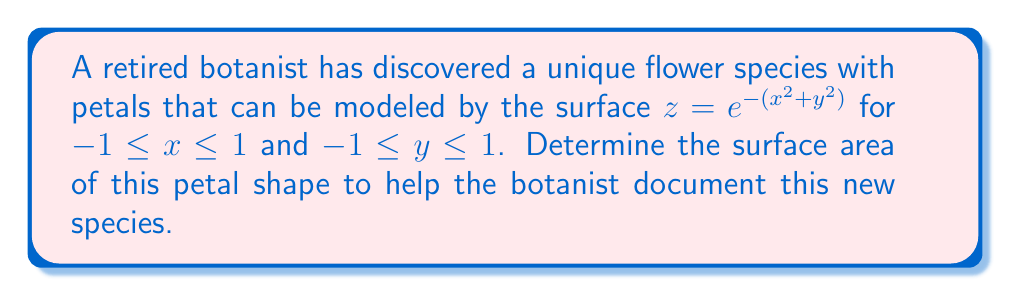Could you help me with this problem? To find the surface area of the petal, we need to use the surface area formula for a parametric surface:

$$A = \int\int_R \sqrt{1 + \left(\frac{\partial z}{\partial x}\right)^2 + \left(\frac{\partial z}{\partial y}\right)^2} \, dA$$

where $R$ is the region of integration.

Step 1: Calculate the partial derivatives
$$\frac{\partial z}{\partial x} = -2xe^{-(x^2+y^2)}$$
$$\frac{\partial z}{\partial y} = -2ye^{-(x^2+y^2)}$$

Step 2: Substitute into the surface area formula
$$A = \int_{-1}^1 \int_{-1}^1 \sqrt{1 + 4x^2e^{-2(x^2+y^2)} + 4y^2e^{-2(x^2+y^2)}} \, dy \, dx$$

Step 3: Simplify the integrand
$$A = \int_{-1}^1 \int_{-1}^1 \sqrt{1 + 4(x^2+y^2)e^{-2(x^2+y^2)}} \, dy \, dx$$

Step 4: This integral cannot be evaluated analytically, so we need to use numerical integration methods. Using a computer algebra system or numerical integration software, we can approximate the value of this double integral.

Step 5: After numerical integration, we get the approximate surface area.
Answer: $A \approx 4.8782$ square units 